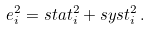<formula> <loc_0><loc_0><loc_500><loc_500>e _ { i } ^ { 2 } = s t a t _ { i } ^ { 2 } + s y s t _ { i } ^ { 2 } \, .</formula> 